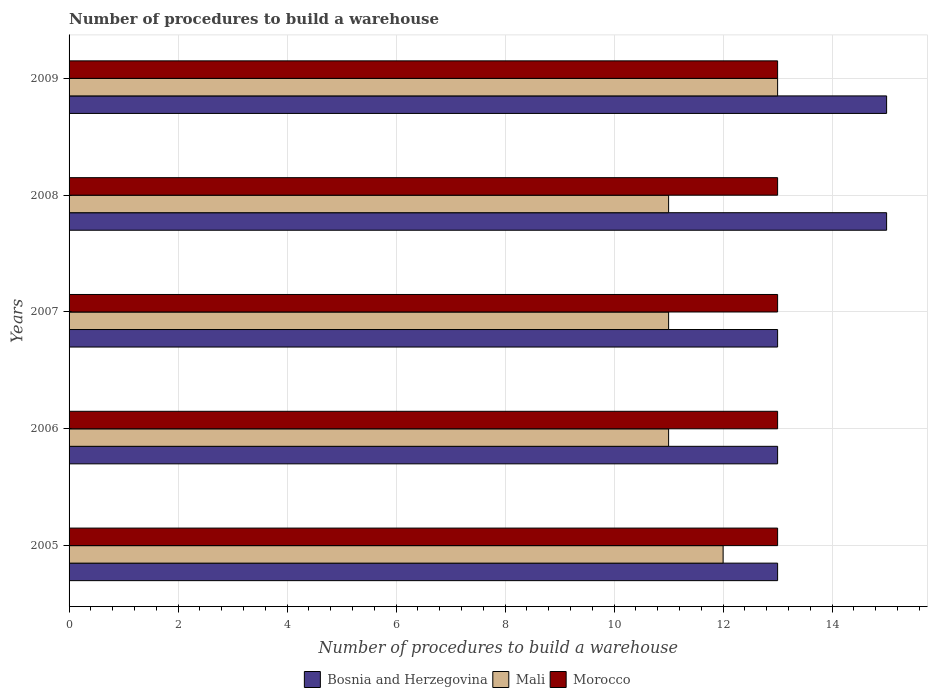How many different coloured bars are there?
Offer a very short reply. 3. How many groups of bars are there?
Your response must be concise. 5. Are the number of bars per tick equal to the number of legend labels?
Give a very brief answer. Yes. How many bars are there on the 1st tick from the top?
Ensure brevity in your answer.  3. How many bars are there on the 1st tick from the bottom?
Provide a short and direct response. 3. What is the label of the 2nd group of bars from the top?
Make the answer very short. 2008. What is the number of procedures to build a warehouse in in Bosnia and Herzegovina in 2005?
Ensure brevity in your answer.  13. Across all years, what is the maximum number of procedures to build a warehouse in in Morocco?
Make the answer very short. 13. Across all years, what is the minimum number of procedures to build a warehouse in in Mali?
Keep it short and to the point. 11. In which year was the number of procedures to build a warehouse in in Morocco minimum?
Ensure brevity in your answer.  2005. What is the total number of procedures to build a warehouse in in Mali in the graph?
Provide a succinct answer. 58. What is the difference between the number of procedures to build a warehouse in in Morocco in 2006 and that in 2008?
Provide a short and direct response. 0. What is the difference between the number of procedures to build a warehouse in in Morocco in 2009 and the number of procedures to build a warehouse in in Bosnia and Herzegovina in 2008?
Make the answer very short. -2. In the year 2009, what is the difference between the number of procedures to build a warehouse in in Bosnia and Herzegovina and number of procedures to build a warehouse in in Morocco?
Your response must be concise. 2. What is the ratio of the number of procedures to build a warehouse in in Mali in 2005 to that in 2006?
Give a very brief answer. 1.09. Is the difference between the number of procedures to build a warehouse in in Bosnia and Herzegovina in 2008 and 2009 greater than the difference between the number of procedures to build a warehouse in in Morocco in 2008 and 2009?
Make the answer very short. No. What is the difference between the highest and the second highest number of procedures to build a warehouse in in Mali?
Your response must be concise. 1. What is the difference between the highest and the lowest number of procedures to build a warehouse in in Morocco?
Your response must be concise. 0. In how many years, is the number of procedures to build a warehouse in in Mali greater than the average number of procedures to build a warehouse in in Mali taken over all years?
Provide a short and direct response. 2. Is the sum of the number of procedures to build a warehouse in in Mali in 2006 and 2009 greater than the maximum number of procedures to build a warehouse in in Morocco across all years?
Offer a terse response. Yes. What does the 2nd bar from the top in 2005 represents?
Give a very brief answer. Mali. What does the 3rd bar from the bottom in 2005 represents?
Your response must be concise. Morocco. Are all the bars in the graph horizontal?
Your answer should be compact. Yes. Are the values on the major ticks of X-axis written in scientific E-notation?
Provide a succinct answer. No. Does the graph contain any zero values?
Keep it short and to the point. No. What is the title of the graph?
Offer a very short reply. Number of procedures to build a warehouse. What is the label or title of the X-axis?
Your response must be concise. Number of procedures to build a warehouse. What is the label or title of the Y-axis?
Offer a very short reply. Years. What is the Number of procedures to build a warehouse in Bosnia and Herzegovina in 2005?
Your answer should be very brief. 13. What is the Number of procedures to build a warehouse of Mali in 2005?
Ensure brevity in your answer.  12. What is the Number of procedures to build a warehouse of Bosnia and Herzegovina in 2006?
Your answer should be compact. 13. What is the Number of procedures to build a warehouse in Mali in 2006?
Your answer should be very brief. 11. What is the Number of procedures to build a warehouse in Morocco in 2007?
Your answer should be compact. 13. What is the Number of procedures to build a warehouse in Bosnia and Herzegovina in 2008?
Provide a short and direct response. 15. What is the Number of procedures to build a warehouse of Mali in 2008?
Offer a very short reply. 11. Across all years, what is the maximum Number of procedures to build a warehouse in Bosnia and Herzegovina?
Your response must be concise. 15. Across all years, what is the maximum Number of procedures to build a warehouse of Mali?
Make the answer very short. 13. Across all years, what is the minimum Number of procedures to build a warehouse of Bosnia and Herzegovina?
Make the answer very short. 13. What is the difference between the Number of procedures to build a warehouse of Bosnia and Herzegovina in 2005 and that in 2006?
Your answer should be compact. 0. What is the difference between the Number of procedures to build a warehouse in Bosnia and Herzegovina in 2005 and that in 2007?
Your answer should be very brief. 0. What is the difference between the Number of procedures to build a warehouse in Morocco in 2005 and that in 2007?
Keep it short and to the point. 0. What is the difference between the Number of procedures to build a warehouse in Bosnia and Herzegovina in 2005 and that in 2008?
Keep it short and to the point. -2. What is the difference between the Number of procedures to build a warehouse of Morocco in 2005 and that in 2009?
Give a very brief answer. 0. What is the difference between the Number of procedures to build a warehouse of Bosnia and Herzegovina in 2006 and that in 2007?
Your response must be concise. 0. What is the difference between the Number of procedures to build a warehouse in Bosnia and Herzegovina in 2006 and that in 2009?
Keep it short and to the point. -2. What is the difference between the Number of procedures to build a warehouse of Mali in 2006 and that in 2009?
Offer a very short reply. -2. What is the difference between the Number of procedures to build a warehouse in Bosnia and Herzegovina in 2007 and that in 2008?
Offer a terse response. -2. What is the difference between the Number of procedures to build a warehouse in Morocco in 2007 and that in 2009?
Your answer should be very brief. 0. What is the difference between the Number of procedures to build a warehouse of Mali in 2008 and that in 2009?
Provide a short and direct response. -2. What is the difference between the Number of procedures to build a warehouse of Bosnia and Herzegovina in 2005 and the Number of procedures to build a warehouse of Mali in 2006?
Make the answer very short. 2. What is the difference between the Number of procedures to build a warehouse in Bosnia and Herzegovina in 2005 and the Number of procedures to build a warehouse in Mali in 2007?
Your answer should be compact. 2. What is the difference between the Number of procedures to build a warehouse of Bosnia and Herzegovina in 2005 and the Number of procedures to build a warehouse of Morocco in 2007?
Provide a short and direct response. 0. What is the difference between the Number of procedures to build a warehouse in Mali in 2005 and the Number of procedures to build a warehouse in Morocco in 2008?
Offer a very short reply. -1. What is the difference between the Number of procedures to build a warehouse in Bosnia and Herzegovina in 2005 and the Number of procedures to build a warehouse in Mali in 2009?
Provide a succinct answer. 0. What is the difference between the Number of procedures to build a warehouse of Bosnia and Herzegovina in 2006 and the Number of procedures to build a warehouse of Mali in 2007?
Keep it short and to the point. 2. What is the difference between the Number of procedures to build a warehouse in Bosnia and Herzegovina in 2006 and the Number of procedures to build a warehouse in Morocco in 2007?
Offer a very short reply. 0. What is the difference between the Number of procedures to build a warehouse in Bosnia and Herzegovina in 2006 and the Number of procedures to build a warehouse in Mali in 2008?
Your response must be concise. 2. What is the difference between the Number of procedures to build a warehouse in Bosnia and Herzegovina in 2006 and the Number of procedures to build a warehouse in Morocco in 2008?
Your answer should be very brief. 0. What is the difference between the Number of procedures to build a warehouse in Bosnia and Herzegovina in 2006 and the Number of procedures to build a warehouse in Mali in 2009?
Ensure brevity in your answer.  0. What is the difference between the Number of procedures to build a warehouse of Bosnia and Herzegovina in 2006 and the Number of procedures to build a warehouse of Morocco in 2009?
Provide a succinct answer. 0. What is the difference between the Number of procedures to build a warehouse in Mali in 2006 and the Number of procedures to build a warehouse in Morocco in 2009?
Your answer should be very brief. -2. What is the difference between the Number of procedures to build a warehouse of Bosnia and Herzegovina in 2007 and the Number of procedures to build a warehouse of Mali in 2008?
Offer a very short reply. 2. What is the difference between the Number of procedures to build a warehouse of Bosnia and Herzegovina in 2007 and the Number of procedures to build a warehouse of Morocco in 2008?
Keep it short and to the point. 0. What is the difference between the Number of procedures to build a warehouse of Bosnia and Herzegovina in 2007 and the Number of procedures to build a warehouse of Morocco in 2009?
Give a very brief answer. 0. What is the difference between the Number of procedures to build a warehouse of Bosnia and Herzegovina in 2008 and the Number of procedures to build a warehouse of Mali in 2009?
Offer a terse response. 2. What is the difference between the Number of procedures to build a warehouse of Bosnia and Herzegovina in 2008 and the Number of procedures to build a warehouse of Morocco in 2009?
Your answer should be compact. 2. In the year 2005, what is the difference between the Number of procedures to build a warehouse in Mali and Number of procedures to build a warehouse in Morocco?
Provide a succinct answer. -1. In the year 2006, what is the difference between the Number of procedures to build a warehouse of Bosnia and Herzegovina and Number of procedures to build a warehouse of Mali?
Provide a short and direct response. 2. In the year 2007, what is the difference between the Number of procedures to build a warehouse in Bosnia and Herzegovina and Number of procedures to build a warehouse in Morocco?
Offer a terse response. 0. In the year 2007, what is the difference between the Number of procedures to build a warehouse of Mali and Number of procedures to build a warehouse of Morocco?
Make the answer very short. -2. In the year 2008, what is the difference between the Number of procedures to build a warehouse of Bosnia and Herzegovina and Number of procedures to build a warehouse of Mali?
Provide a succinct answer. 4. In the year 2008, what is the difference between the Number of procedures to build a warehouse in Mali and Number of procedures to build a warehouse in Morocco?
Ensure brevity in your answer.  -2. What is the ratio of the Number of procedures to build a warehouse of Bosnia and Herzegovina in 2005 to that in 2006?
Your answer should be compact. 1. What is the ratio of the Number of procedures to build a warehouse of Mali in 2005 to that in 2006?
Your answer should be very brief. 1.09. What is the ratio of the Number of procedures to build a warehouse of Bosnia and Herzegovina in 2005 to that in 2007?
Keep it short and to the point. 1. What is the ratio of the Number of procedures to build a warehouse in Morocco in 2005 to that in 2007?
Your response must be concise. 1. What is the ratio of the Number of procedures to build a warehouse of Bosnia and Herzegovina in 2005 to that in 2008?
Ensure brevity in your answer.  0.87. What is the ratio of the Number of procedures to build a warehouse of Bosnia and Herzegovina in 2005 to that in 2009?
Give a very brief answer. 0.87. What is the ratio of the Number of procedures to build a warehouse in Mali in 2005 to that in 2009?
Make the answer very short. 0.92. What is the ratio of the Number of procedures to build a warehouse in Morocco in 2006 to that in 2007?
Provide a short and direct response. 1. What is the ratio of the Number of procedures to build a warehouse of Bosnia and Herzegovina in 2006 to that in 2008?
Offer a very short reply. 0.87. What is the ratio of the Number of procedures to build a warehouse of Morocco in 2006 to that in 2008?
Offer a terse response. 1. What is the ratio of the Number of procedures to build a warehouse in Bosnia and Herzegovina in 2006 to that in 2009?
Your response must be concise. 0.87. What is the ratio of the Number of procedures to build a warehouse of Mali in 2006 to that in 2009?
Your answer should be very brief. 0.85. What is the ratio of the Number of procedures to build a warehouse in Morocco in 2006 to that in 2009?
Provide a short and direct response. 1. What is the ratio of the Number of procedures to build a warehouse of Bosnia and Herzegovina in 2007 to that in 2008?
Ensure brevity in your answer.  0.87. What is the ratio of the Number of procedures to build a warehouse in Morocco in 2007 to that in 2008?
Provide a succinct answer. 1. What is the ratio of the Number of procedures to build a warehouse in Bosnia and Herzegovina in 2007 to that in 2009?
Make the answer very short. 0.87. What is the ratio of the Number of procedures to build a warehouse in Mali in 2007 to that in 2009?
Provide a succinct answer. 0.85. What is the ratio of the Number of procedures to build a warehouse in Bosnia and Herzegovina in 2008 to that in 2009?
Provide a short and direct response. 1. What is the ratio of the Number of procedures to build a warehouse in Mali in 2008 to that in 2009?
Your response must be concise. 0.85. What is the ratio of the Number of procedures to build a warehouse in Morocco in 2008 to that in 2009?
Ensure brevity in your answer.  1. What is the difference between the highest and the second highest Number of procedures to build a warehouse of Mali?
Offer a terse response. 1. What is the difference between the highest and the second highest Number of procedures to build a warehouse in Morocco?
Your answer should be compact. 0. 